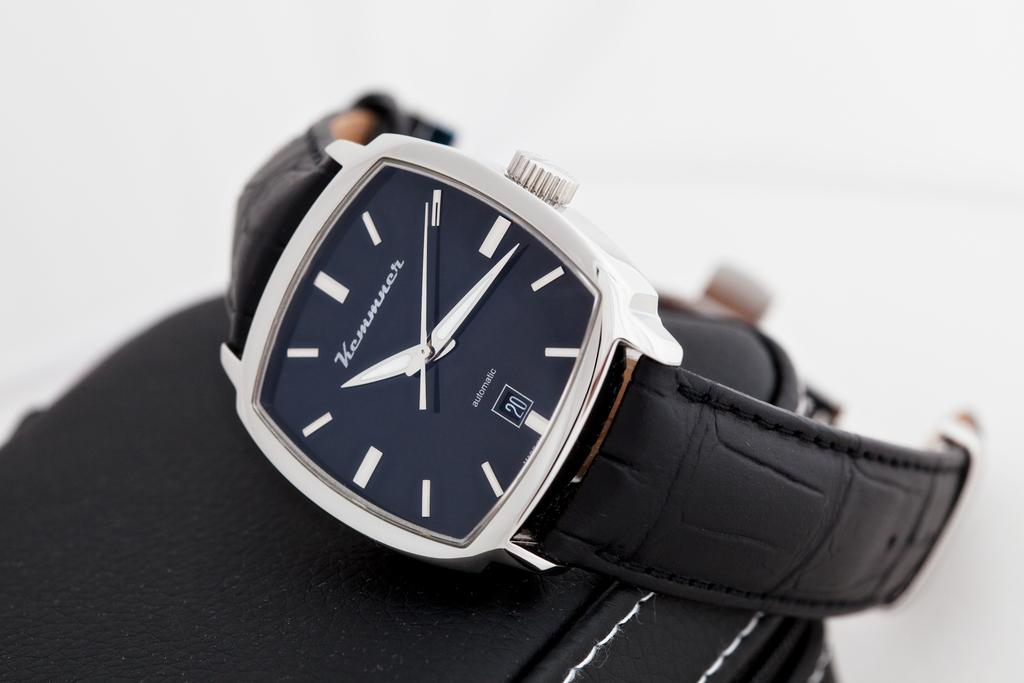<image>
Describe the image concisely. A silver wristwatch with a black leather band says Kemmrur. 